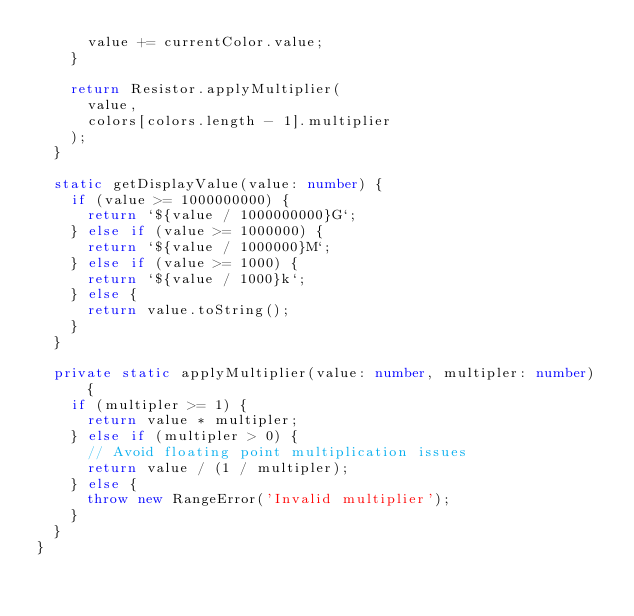Convert code to text. <code><loc_0><loc_0><loc_500><loc_500><_TypeScript_>      value += currentColor.value;
    }

    return Resistor.applyMultiplier(
      value,
      colors[colors.length - 1].multiplier
    );
  }

  static getDisplayValue(value: number) {
    if (value >= 1000000000) {
      return `${value / 1000000000}G`;
    } else if (value >= 1000000) {
      return `${value / 1000000}M`;
    } else if (value >= 1000) {
      return `${value / 1000}k`;
    } else {
      return value.toString();
    }
  }

  private static applyMultiplier(value: number, multipler: number) {
    if (multipler >= 1) {
      return value * multipler;
    } else if (multipler > 0) {
      // Avoid floating point multiplication issues
      return value / (1 / multipler);
    } else {
      throw new RangeError('Invalid multiplier');
    }
  }
}
</code> 